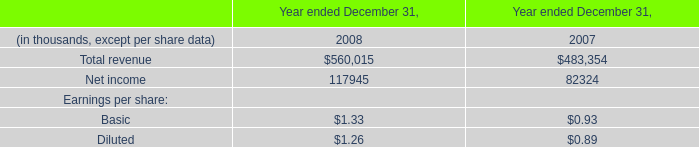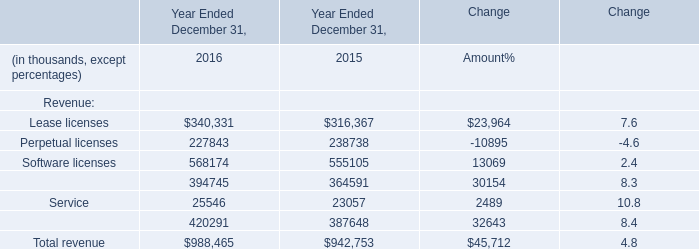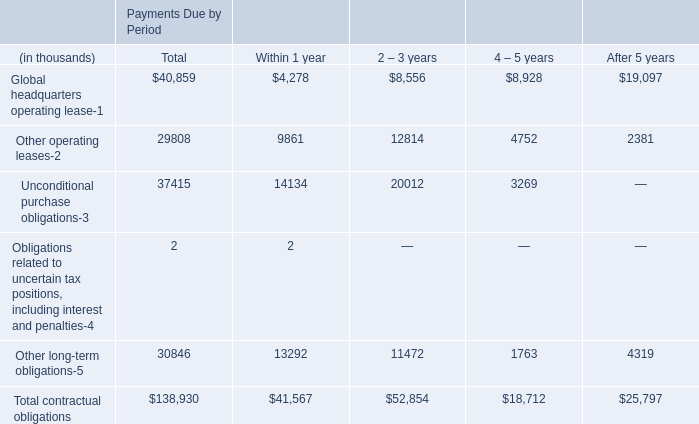What's the average of Net income of data 0 2008, and Software licenses of Year Ended December 31, 2015 ? 
Computations: ((117945.0 + 555105.0) / 2)
Answer: 336525.0. 